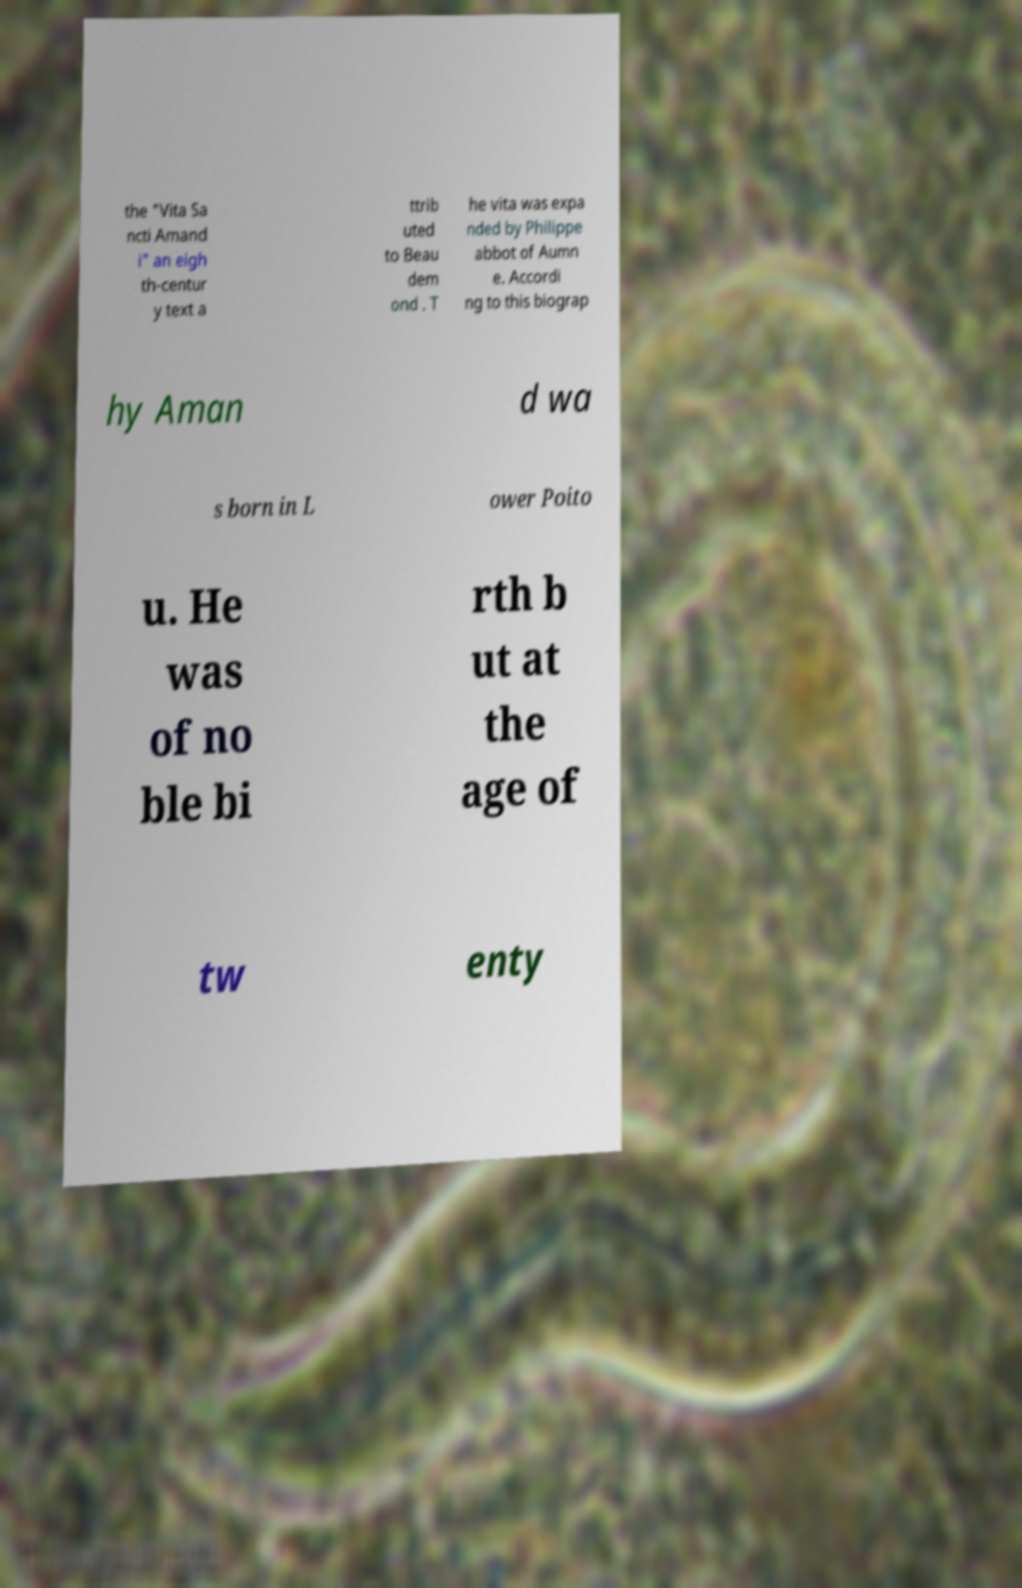Please identify and transcribe the text found in this image. the "Vita Sa ncti Amand i" an eigh th-centur y text a ttrib uted to Beau dem ond . T he vita was expa nded by Philippe abbot of Aumn e. Accordi ng to this biograp hy Aman d wa s born in L ower Poito u. He was of no ble bi rth b ut at the age of tw enty 